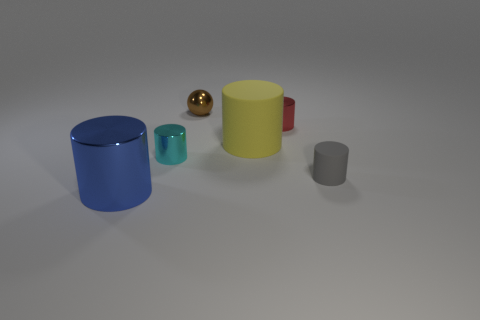Can you tell me what the small golden object is in the image? The small golden object looks like a simple, highly reflective sphere. It could represent a metal ball bearing or be a decorative element, given the context of the image. 